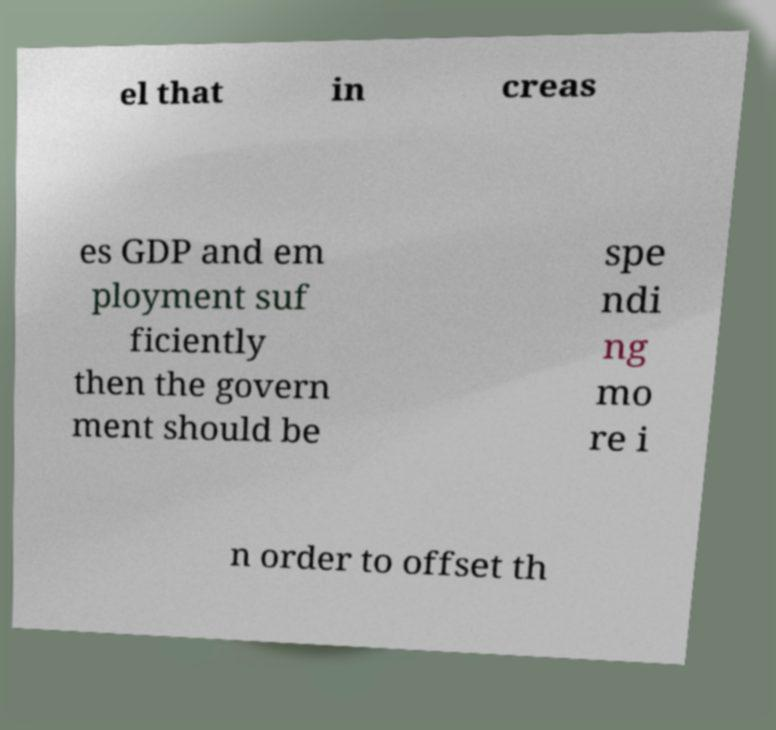Please read and relay the text visible in this image. What does it say? el that in creas es GDP and em ployment suf ficiently then the govern ment should be spe ndi ng mo re i n order to offset th 